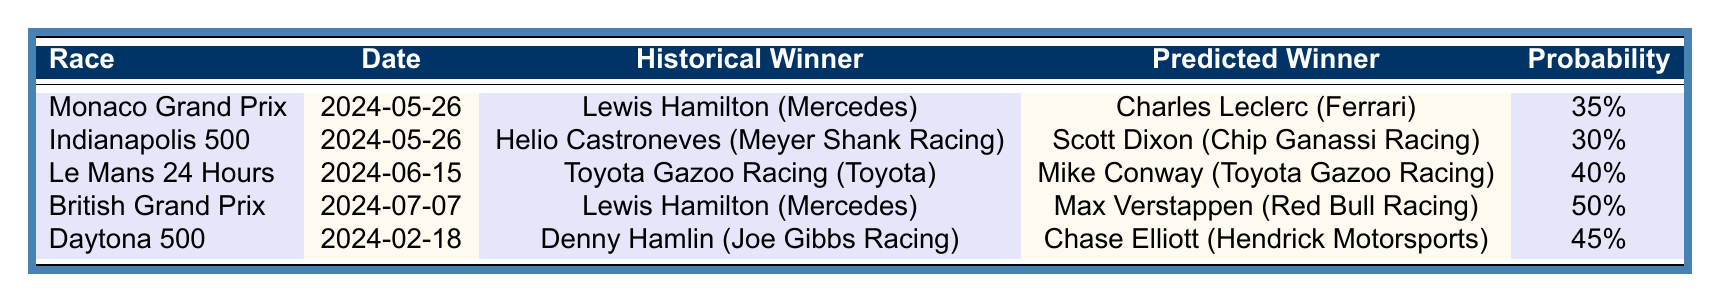What is the predicted winner of the Monaco Grand Prix? The table lists the predicted winner for the Monaco Grand Prix as Charles Leclerc from Ferrari.
Answer: Charles Leclerc How many wins does Mercedes have in the last 5 years for the Monaco Grand Prix? According to the table, Mercedes has won the Monaco Grand Prix 3 times in the last 5 years.
Answer: 3 wins What is the weather forecast for the Daytona 500? The table indicates that the weather forecast for the Daytona 500 is clear.
Answer: Clear Which race has the highest predicted winner probability? The British Grand Prix has the highest predicted winner probability at 50%.
Answer: 50% Who won the Indianapolis 500 historically? The table shows that the historical winner of the Indianapolis 500 is Helio Castroneves from Meyer Shank Racing.
Answer: Helio Castroneves Is the average start position for the Le Mans 24 Hours lower than that of the Daytona 500? The average start position for Le Mans is 3.0, which is lower than Daytona's average start position of 8.2, confirming the statement.
Answer: Yes What is the total wins of historical winners for the races listed? Summing the wins: 3 (Monaco) + 1 (Indy) + 4 (Le Mans) + 3 (British) + 2 (Daytona) gives a total of 13 wins.
Answer: 13 wins Which driver has a better predicted winning probability, Mike Conway or Scott Dixon? The table indicates that Mike Conway has a probability of 40%, while Scott Dixon has 30%. Therefore, Mike Conway has a better probability.
Answer: Mike Conway What is the predicted winner for the British Grand Prix and their team? According to the table, the predicted winner for the British Grand Prix is Max Verstappen from Red Bull Racing.
Answer: Max Verstappen (Red Bull Racing) How does the average start position for the British Grand Prix compare to the Indianapolis 500? The average start position for the British Grand Prix is 1.4, which is lower than the Indianapolis 500 average start position of 5.9, indicating a better starting spot.
Answer: Lower 